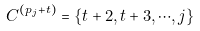Convert formula to latex. <formula><loc_0><loc_0><loc_500><loc_500>C ^ { ( p _ { j } + t ) } = \{ t + 2 , t + 3 , \cdots , j \}</formula> 